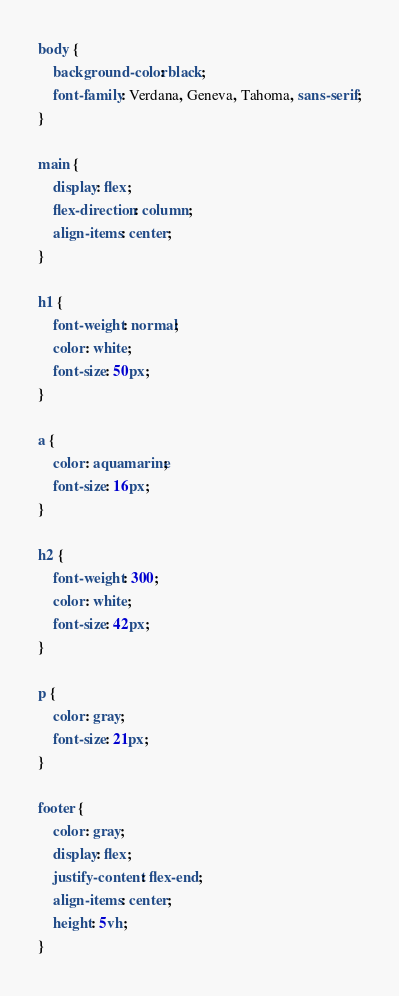<code> <loc_0><loc_0><loc_500><loc_500><_CSS_>body {
    background-color: black;
    font-family: Verdana, Geneva, Tahoma, sans-serif;
}

main {
    display: flex;
    flex-direction: column;
    align-items: center;
}

h1 {
    font-weight: normal;
    color: white;
    font-size: 50px;
}

a {
    color: aquamarine;
    font-size: 16px;
}

h2 {
    font-weight: 300;
    color: white;
    font-size: 42px;
}

p {
    color: gray;
    font-size: 21px;
}

footer {
    color: gray;
    display: flex;
    justify-content: flex-end;
    align-items: center;
    height: 5vh;
}</code> 